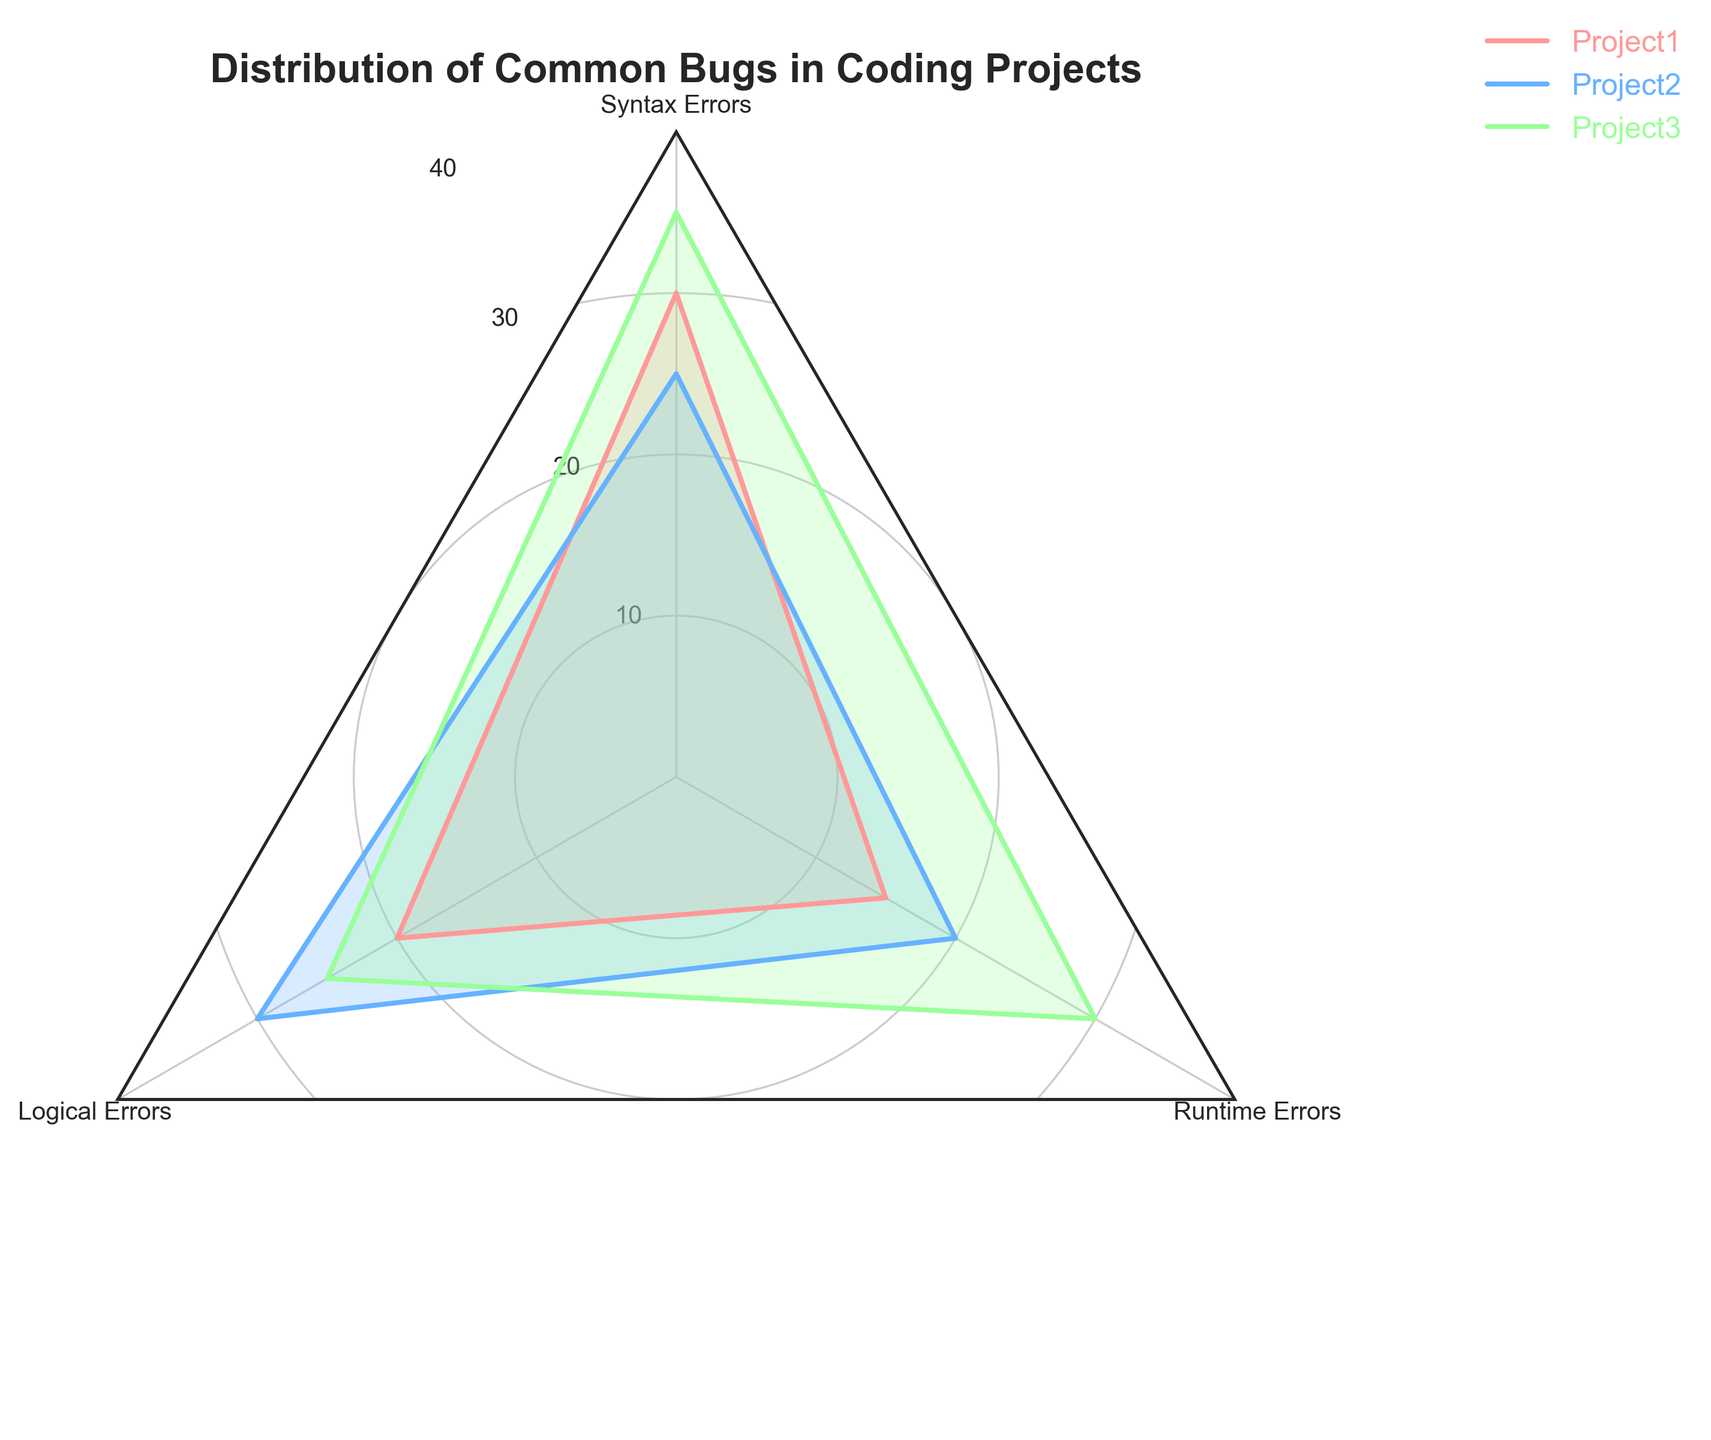What's the title of the figure? The title is prominently displayed at the top of the radar chart and summarizes the main theme of the plot.
Answer: Distribution of Common Bugs in Coding Projects How many categories of bugs are shown in the radar chart? By looking at the plot, we can count the labels around the radar chart.
Answer: 3 Which project has the highest number of Syntax Errors? By comparing the values for Syntax Errors in the radar chart, we can see that Project3 has the highest value.
Answer: Project3 What is the total number of Runtime Errors across all projects? We sum the Runtime Errors from all three projects: 15 (Project1) + 20 (Project2) + 30 (Project3).
Answer: 65 Between Project1 and Project2, which project has more Logical Errors? By visually comparing the Logical Errors for Project1 and Project2 on the radar chart, we can see that Project2 has a higher value.
Answer: Project2 What is the color used to represent Project2 in the radar chart? Each project is represented by a different color in the legend. Project2 is blue.
Answer: Blue What's the average number of bugs across all categories for Project1? Sum the bugs for Project1 and divide by the number of categories: (30 + 20 + 15) / 3.
Answer: 21.67 Which category of bugs shows the most variance across the three projects? By visually comparing each category across the three projects, Runtime Errors show the most difference in values.
Answer: Runtime Errors Are there any categories where all projects have the same number of bugs? By looking at each category for all projects, none have the same number of bugs across all projects.
Answer: No 